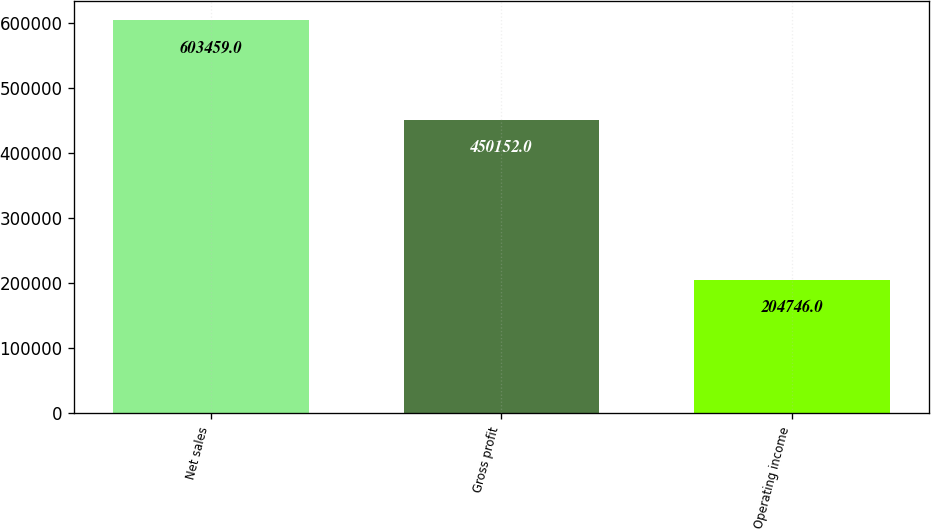Convert chart. <chart><loc_0><loc_0><loc_500><loc_500><bar_chart><fcel>Net sales<fcel>Gross profit<fcel>Operating income<nl><fcel>603459<fcel>450152<fcel>204746<nl></chart> 